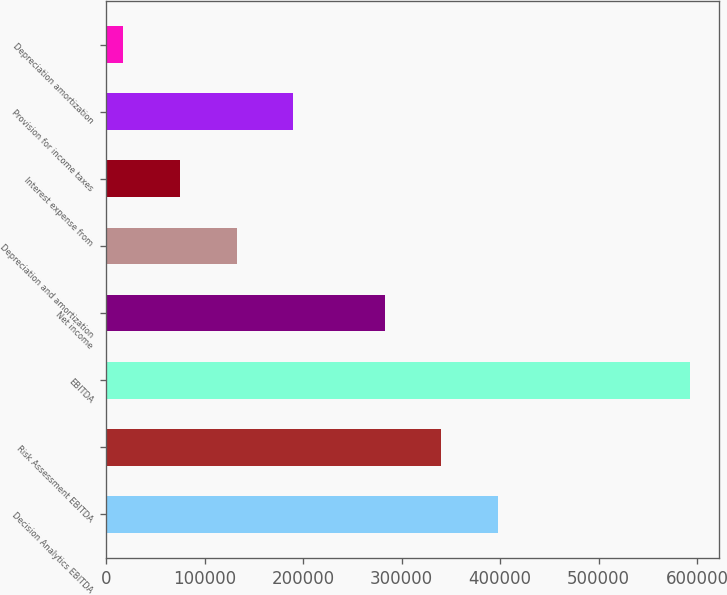<chart> <loc_0><loc_0><loc_500><loc_500><bar_chart><fcel>Decision Analytics EBITDA<fcel>Risk Assessment EBITDA<fcel>EBITDA<fcel>Net income<fcel>Depreciation and amortization<fcel>Interest expense from<fcel>Provision for income taxes<fcel>Depreciation amortization<nl><fcel>397851<fcel>340304<fcel>592887<fcel>282758<fcel>132516<fcel>74969.4<fcel>190062<fcel>17423<nl></chart> 